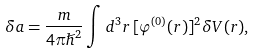Convert formula to latex. <formula><loc_0><loc_0><loc_500><loc_500>\delta a = \frac { m } { 4 \pi \hslash ^ { 2 } } \int d ^ { 3 } r \, [ \varphi ^ { ( 0 ) } ( r ) ] ^ { 2 } \delta V ( r ) ,</formula> 